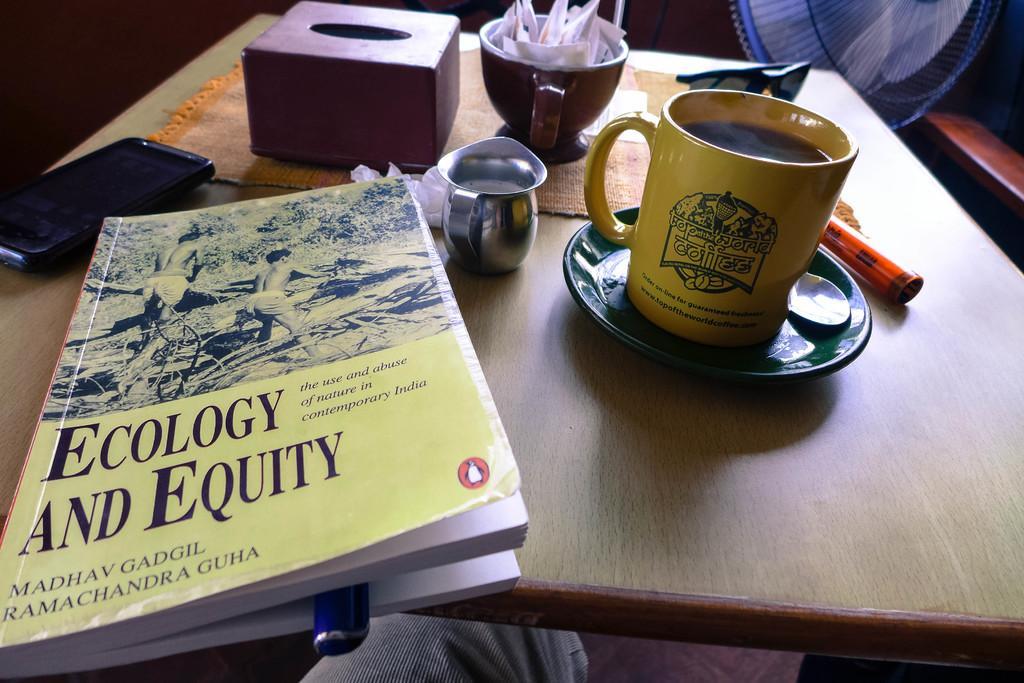Please provide a concise description of this image. This image consists of a table and on the table there is a phone on the left side and book in the middle book also has a pen in it and cup and saucer and spoon on the right side and there is a jar in the middle and a cup which consists of a salt and sugar. There is also a tissue book. 